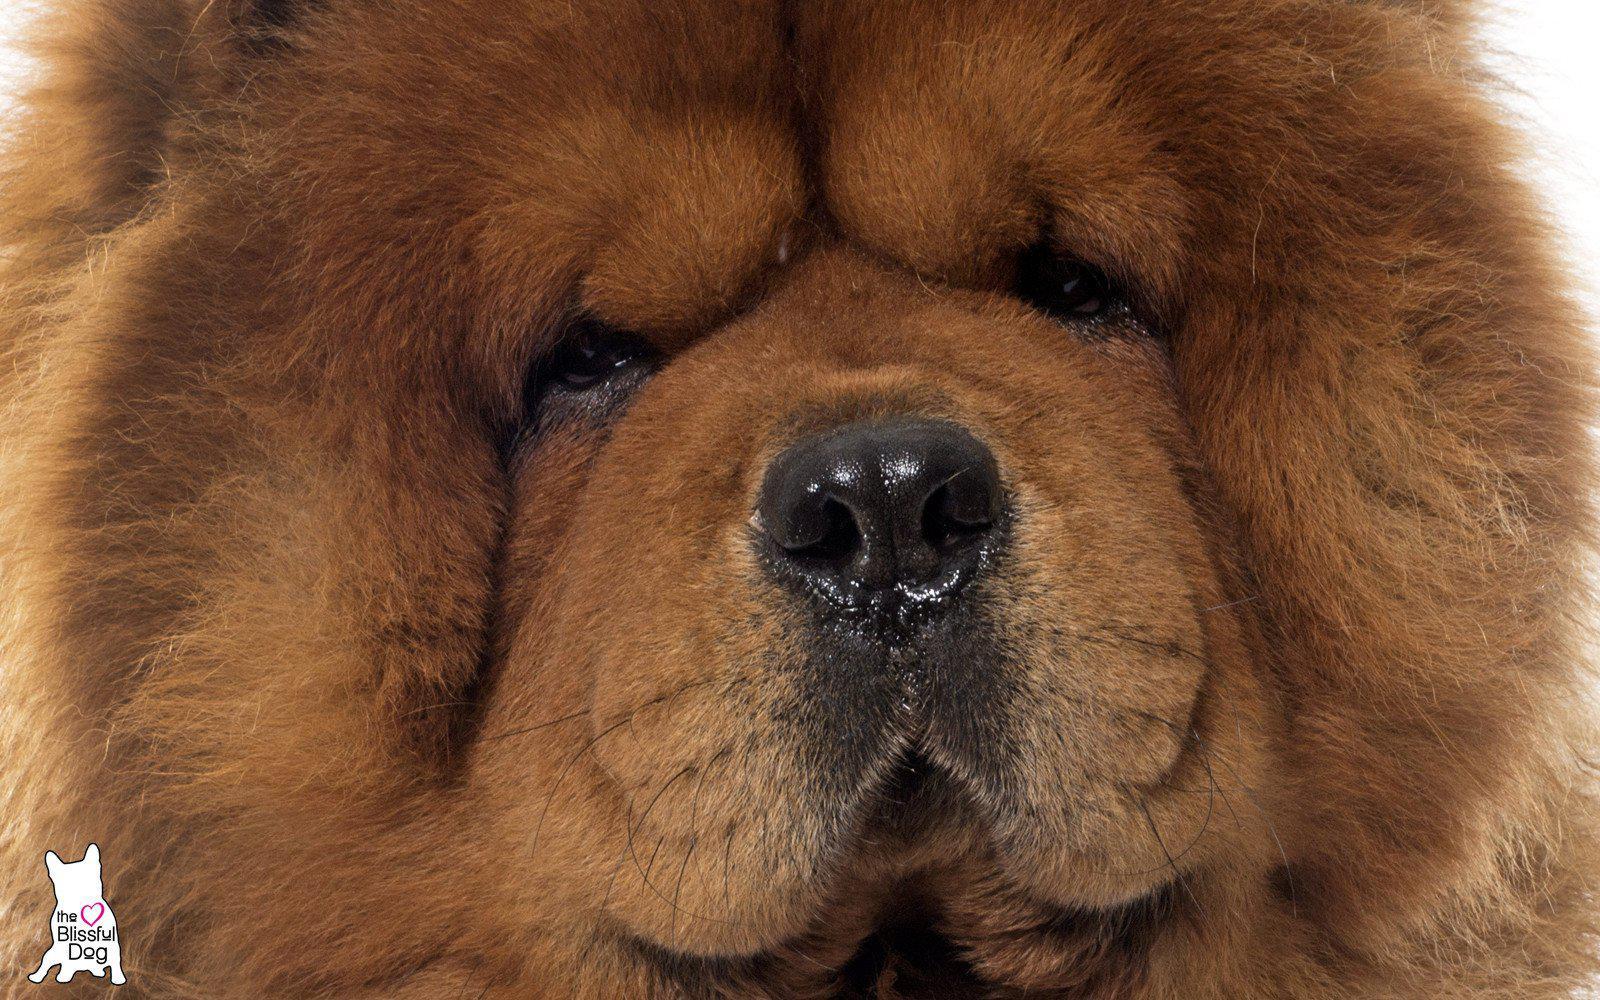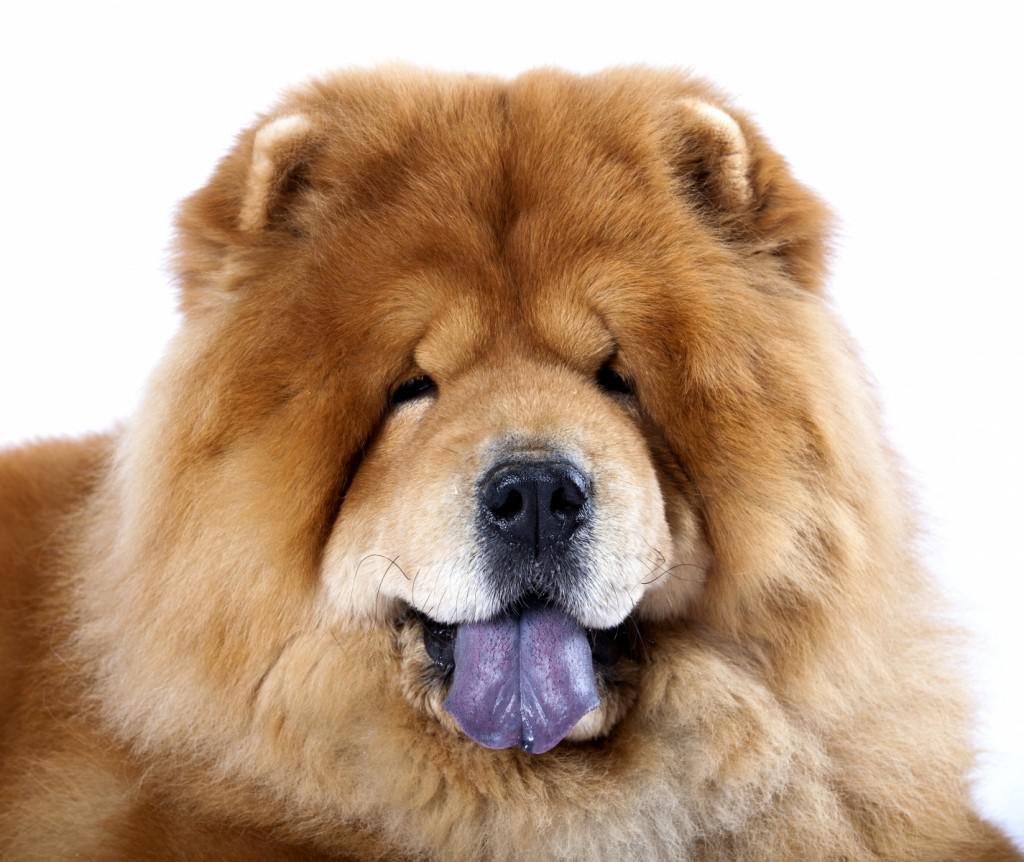The first image is the image on the left, the second image is the image on the right. Analyze the images presented: Is the assertion "Two dog tongues are visible" valid? Answer yes or no. No. 